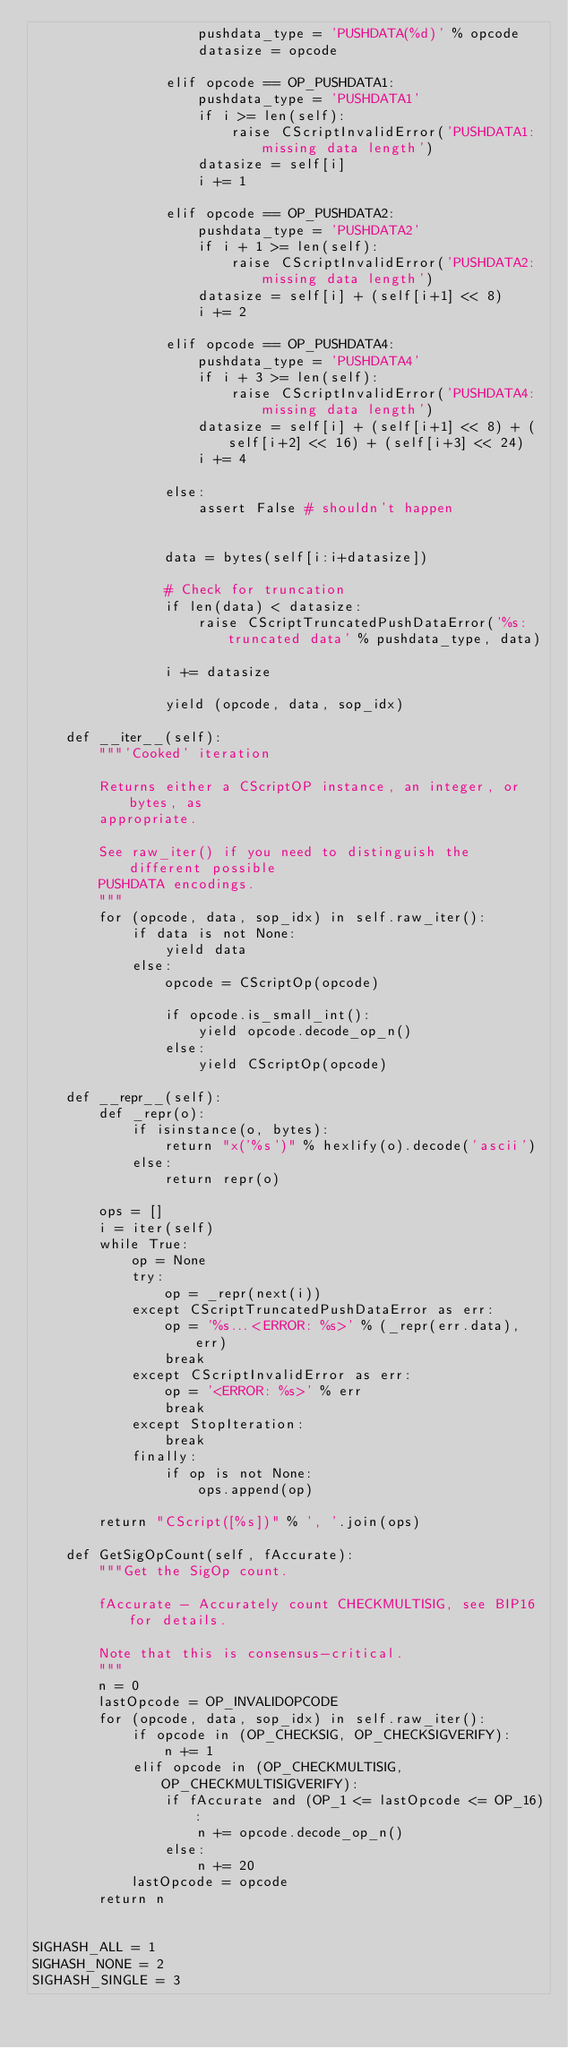<code> <loc_0><loc_0><loc_500><loc_500><_Python_>                    pushdata_type = 'PUSHDATA(%d)' % opcode
                    datasize = opcode

                elif opcode == OP_PUSHDATA1:
                    pushdata_type = 'PUSHDATA1'
                    if i >= len(self):
                        raise CScriptInvalidError('PUSHDATA1: missing data length')
                    datasize = self[i]
                    i += 1

                elif opcode == OP_PUSHDATA2:
                    pushdata_type = 'PUSHDATA2'
                    if i + 1 >= len(self):
                        raise CScriptInvalidError('PUSHDATA2: missing data length')
                    datasize = self[i] + (self[i+1] << 8)
                    i += 2

                elif opcode == OP_PUSHDATA4:
                    pushdata_type = 'PUSHDATA4'
                    if i + 3 >= len(self):
                        raise CScriptInvalidError('PUSHDATA4: missing data length')
                    datasize = self[i] + (self[i+1] << 8) + (self[i+2] << 16) + (self[i+3] << 24)
                    i += 4

                else:
                    assert False # shouldn't happen


                data = bytes(self[i:i+datasize])

                # Check for truncation
                if len(data) < datasize:
                    raise CScriptTruncatedPushDataError('%s: truncated data' % pushdata_type, data)

                i += datasize

                yield (opcode, data, sop_idx)

    def __iter__(self):
        """'Cooked' iteration

        Returns either a CScriptOP instance, an integer, or bytes, as
        appropriate.

        See raw_iter() if you need to distinguish the different possible
        PUSHDATA encodings.
        """
        for (opcode, data, sop_idx) in self.raw_iter():
            if data is not None:
                yield data
            else:
                opcode = CScriptOp(opcode)

                if opcode.is_small_int():
                    yield opcode.decode_op_n()
                else:
                    yield CScriptOp(opcode)

    def __repr__(self):
        def _repr(o):
            if isinstance(o, bytes):
                return "x('%s')" % hexlify(o).decode('ascii')
            else:
                return repr(o)

        ops = []
        i = iter(self)
        while True:
            op = None
            try:
                op = _repr(next(i))
            except CScriptTruncatedPushDataError as err:
                op = '%s...<ERROR: %s>' % (_repr(err.data), err)
                break
            except CScriptInvalidError as err:
                op = '<ERROR: %s>' % err
                break
            except StopIteration:
                break
            finally:
                if op is not None:
                    ops.append(op)

        return "CScript([%s])" % ', '.join(ops)

    def GetSigOpCount(self, fAccurate):
        """Get the SigOp count.

        fAccurate - Accurately count CHECKMULTISIG, see BIP16 for details.

        Note that this is consensus-critical.
        """
        n = 0
        lastOpcode = OP_INVALIDOPCODE
        for (opcode, data, sop_idx) in self.raw_iter():
            if opcode in (OP_CHECKSIG, OP_CHECKSIGVERIFY):
                n += 1
            elif opcode in (OP_CHECKMULTISIG, OP_CHECKMULTISIGVERIFY):
                if fAccurate and (OP_1 <= lastOpcode <= OP_16):
                    n += opcode.decode_op_n()
                else:
                    n += 20
            lastOpcode = opcode
        return n


SIGHASH_ALL = 1
SIGHASH_NONE = 2
SIGHASH_SINGLE = 3</code> 